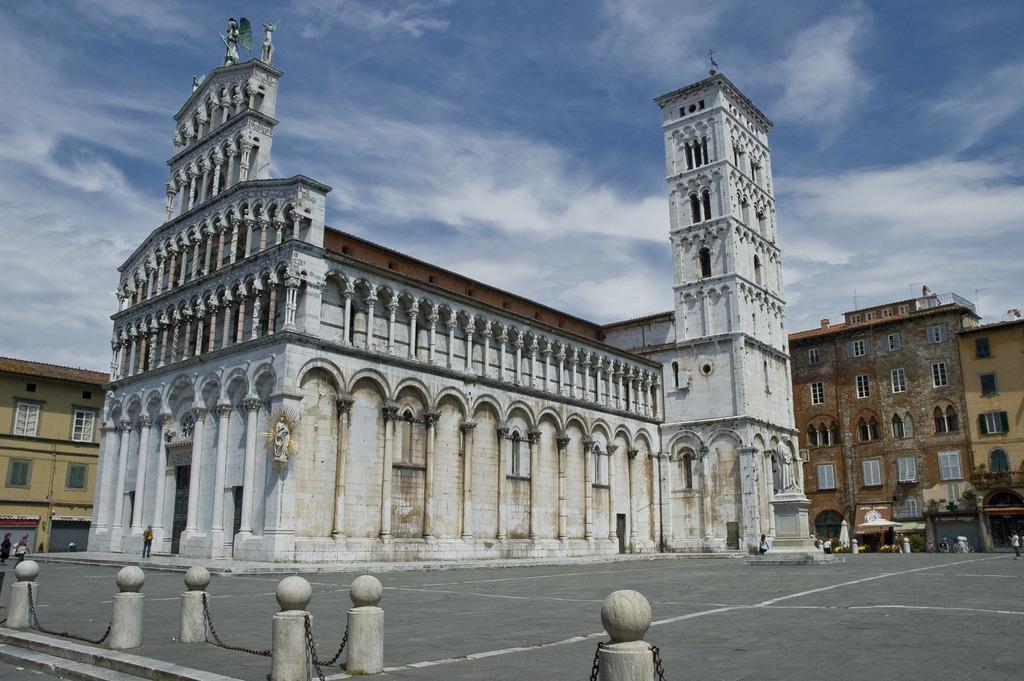How would you summarize this image in a sentence or two? In this image we can see buildings, persons and tents. At the bottom of the image we can see chains and pillars. In the background we can see sky and clouds. 